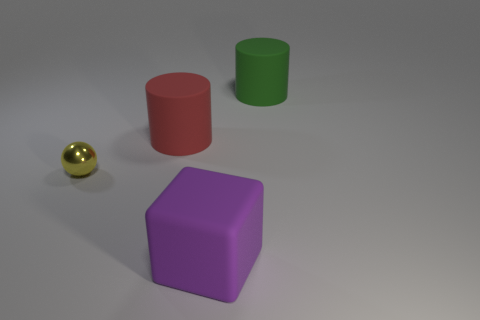Add 2 tiny yellow spheres. How many objects exist? 6 Subtract all blocks. How many objects are left? 3 Add 4 green rubber cylinders. How many green rubber cylinders exist? 5 Subtract 0 red spheres. How many objects are left? 4 Subtract all purple spheres. Subtract all big cubes. How many objects are left? 3 Add 2 tiny things. How many tiny things are left? 3 